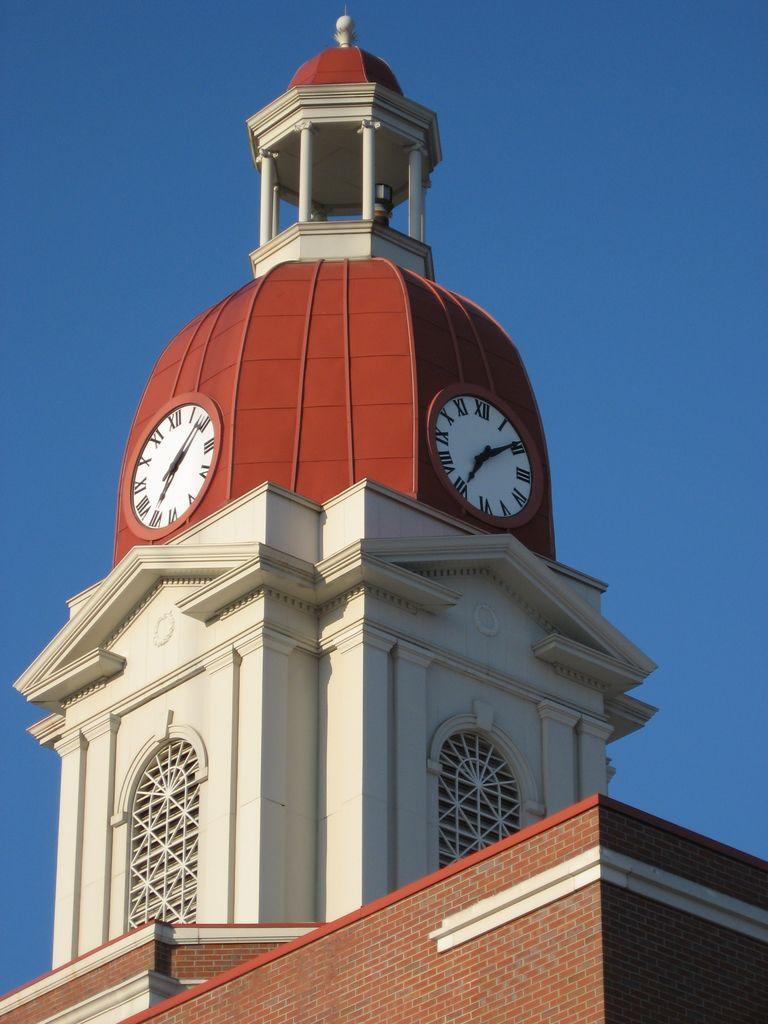Can you describe this image briefly? The picture consists of a building, at the top of the building we can see clocks. At the top it is sky. 